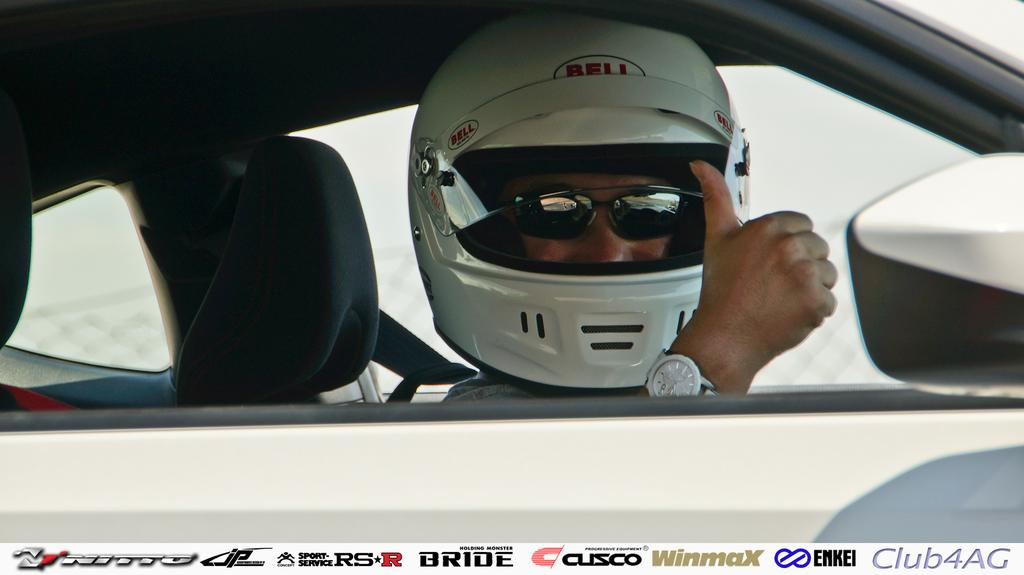Who is the main subject in the image? There is a man in the center of the image. What is the man doing in the image? The man is inside a car. What protective gear is the man wearing? The man is wearing a helmet. What else can be seen on the man's face in the image? The man is wearing glasses. What type of cakes can be seen on the dashboard of the car in the image? There are no cakes present in the image; the man is wearing a helmet and glasses while inside a car. 